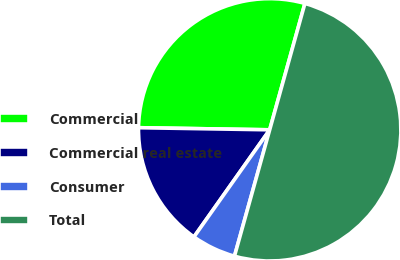<chart> <loc_0><loc_0><loc_500><loc_500><pie_chart><fcel>Commercial<fcel>Commercial real estate<fcel>Consumer<fcel>Total<nl><fcel>29.07%<fcel>15.46%<fcel>5.47%<fcel>50.0%<nl></chart> 